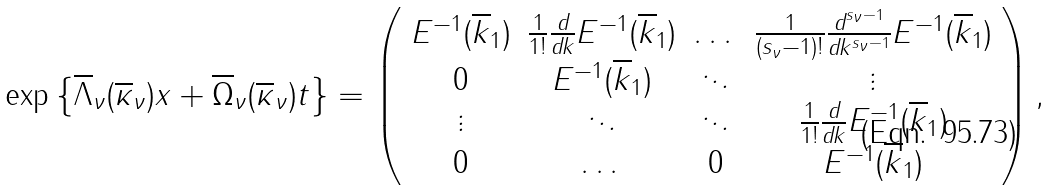Convert formula to latex. <formula><loc_0><loc_0><loc_500><loc_500>\exp \left \{ \overline { \Lambda } _ { \nu } ( \overline { \kappa } _ { \nu } ) x + \overline { \Omega } _ { \nu } ( \overline { \kappa } _ { \nu } ) t \right \} = \left ( \begin{array} { c c c c } E ^ { - 1 } ( \overline { k } _ { 1 } ) & \frac { 1 } { 1 ! } \frac { \text {d} } { \text {d} k } E ^ { - 1 } ( \overline { k } _ { 1 } ) & \dots & \frac { 1 } { ( s _ { \nu } - 1 ) ! } \frac { \text {d} ^ { s _ { \nu } - 1 } } { \text {d} k ^ { s _ { \nu } - 1 } } E ^ { - 1 } ( \overline { k } _ { 1 } ) \\ 0 & E ^ { - 1 } ( \overline { k } _ { 1 } ) & \ddots & \vdots \\ \vdots & \ddots & \ddots & \frac { 1 } { 1 ! } \frac { \text {d} } { \text {d} k } E ^ { - 1 } ( \overline { k } _ { 1 } ) \\ 0 & \dots & 0 & E ^ { - 1 } ( \overline { k } _ { 1 } ) \end{array} \right ) ,</formula> 